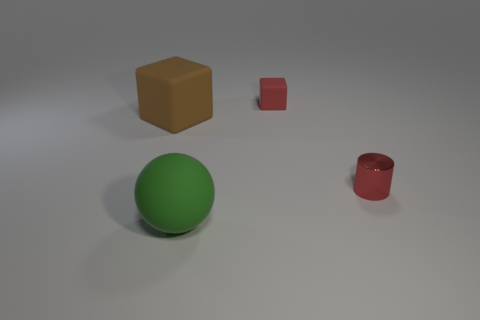There is a matte object that is the same color as the cylinder; what is its size?
Offer a terse response. Small. Is the material of the big thing that is in front of the red shiny thing the same as the brown block?
Your answer should be compact. Yes. Are there fewer large matte objects that are left of the large sphere than cyan cylinders?
Your answer should be very brief. No. There is a cylinder that is the same size as the red rubber object; what is its color?
Provide a short and direct response. Red. What number of other big brown things have the same shape as the big brown matte thing?
Your answer should be very brief. 0. What color is the small thing behind the tiny metal cylinder?
Make the answer very short. Red. What number of shiny objects are either big balls or large objects?
Ensure brevity in your answer.  0. There is a shiny object that is the same color as the small matte cube; what is its shape?
Provide a short and direct response. Cylinder. How many matte blocks are the same size as the red shiny cylinder?
Ensure brevity in your answer.  1. What color is the thing that is both behind the large green rubber sphere and in front of the brown rubber block?
Offer a very short reply. Red. 